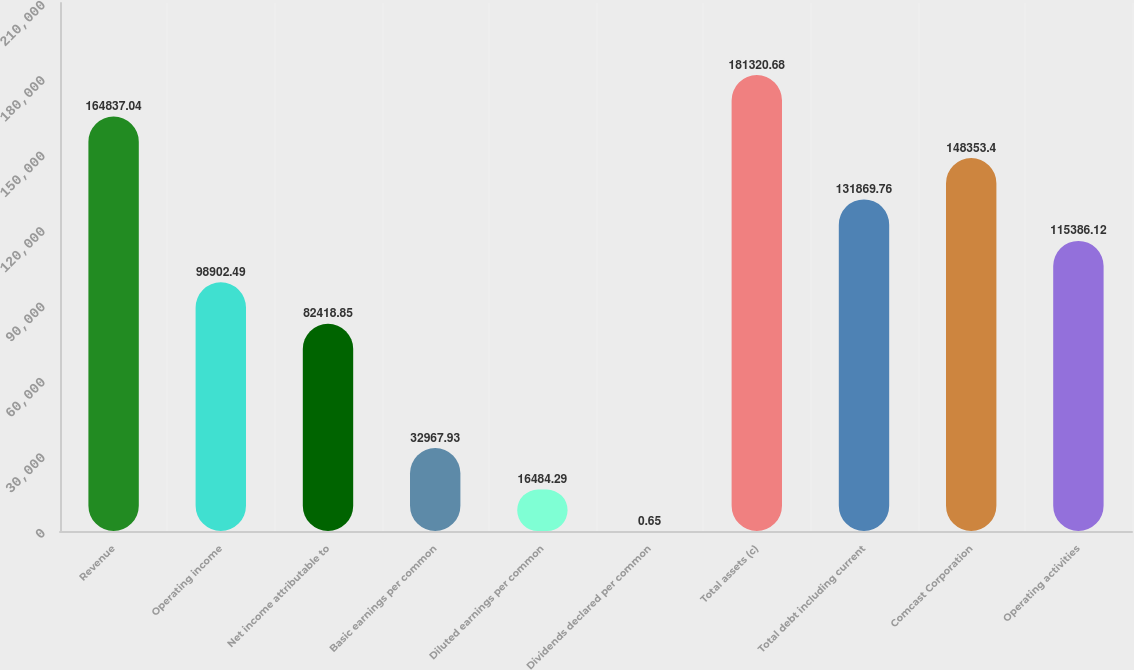<chart> <loc_0><loc_0><loc_500><loc_500><bar_chart><fcel>Revenue<fcel>Operating income<fcel>Net income attributable to<fcel>Basic earnings per common<fcel>Diluted earnings per common<fcel>Dividends declared per common<fcel>Total assets (c)<fcel>Total debt including current<fcel>Comcast Corporation<fcel>Operating activities<nl><fcel>164837<fcel>98902.5<fcel>82418.9<fcel>32967.9<fcel>16484.3<fcel>0.65<fcel>181321<fcel>131870<fcel>148353<fcel>115386<nl></chart> 